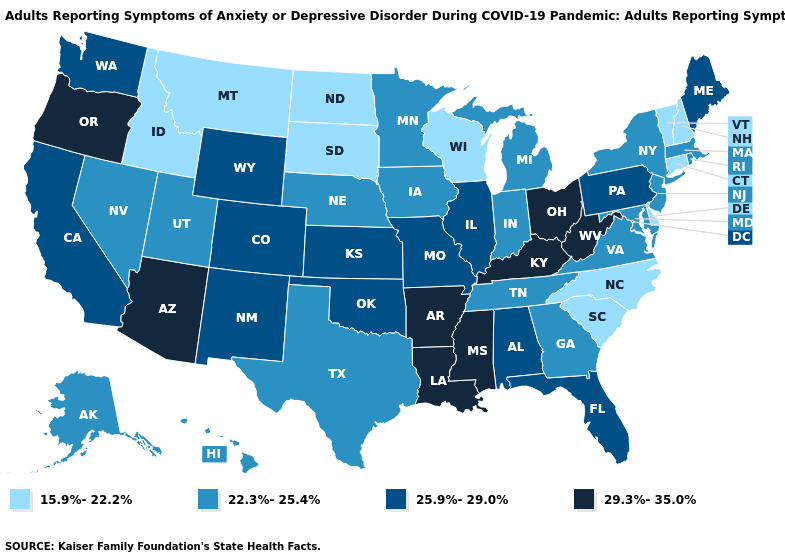What is the value of Alaska?
Short answer required. 22.3%-25.4%. Among the states that border Alabama , does Florida have the lowest value?
Concise answer only. No. Name the states that have a value in the range 29.3%-35.0%?
Quick response, please. Arizona, Arkansas, Kentucky, Louisiana, Mississippi, Ohio, Oregon, West Virginia. What is the value of Maine?
Keep it brief. 25.9%-29.0%. Does Texas have a higher value than Connecticut?
Answer briefly. Yes. Among the states that border Minnesota , does South Dakota have the highest value?
Give a very brief answer. No. What is the value of Missouri?
Be succinct. 25.9%-29.0%. What is the highest value in the South ?
Answer briefly. 29.3%-35.0%. Which states have the lowest value in the USA?
Concise answer only. Connecticut, Delaware, Idaho, Montana, New Hampshire, North Carolina, North Dakota, South Carolina, South Dakota, Vermont, Wisconsin. Does Wisconsin have the highest value in the MidWest?
Quick response, please. No. What is the value of South Dakota?
Quick response, please. 15.9%-22.2%. Does Washington have the highest value in the West?
Answer briefly. No. Does the map have missing data?
Quick response, please. No. Does Pennsylvania have the highest value in the Northeast?
Concise answer only. Yes. Among the states that border Virginia , does West Virginia have the highest value?
Answer briefly. Yes. 